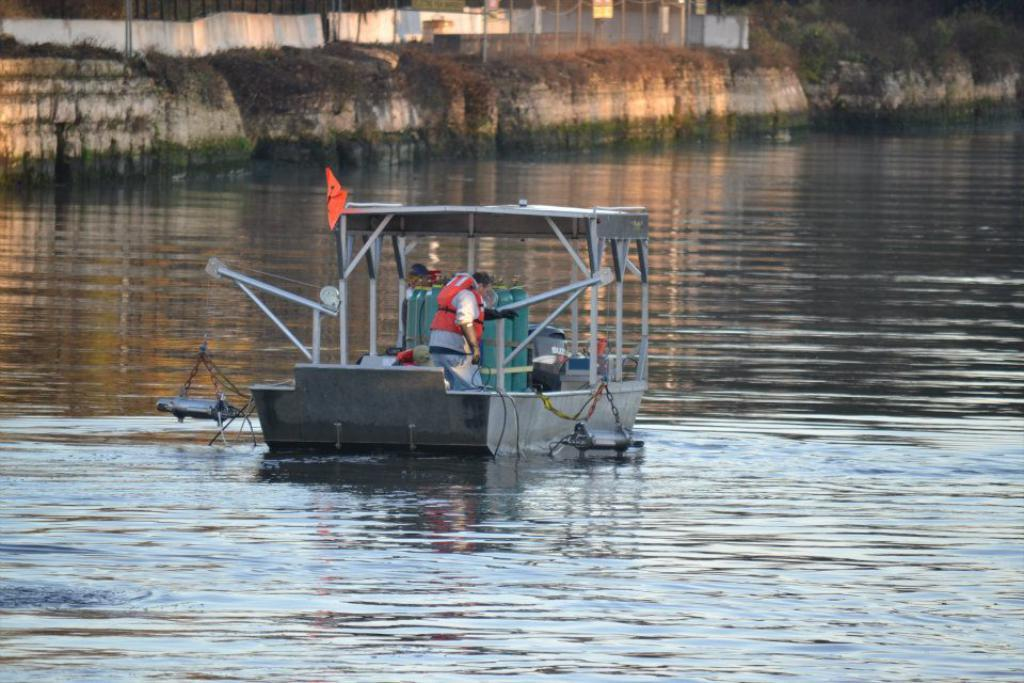What are the people doing in the image? The people are in a boat in the image. Where is the boat located? The boat is on the water. What can be seen in the background of the image? There is a wall, poles, a fence, and a group of trees visible in the image. What type of power source is used to propel the boat in the image? The image does not provide information about the power source used to propel the boat. 